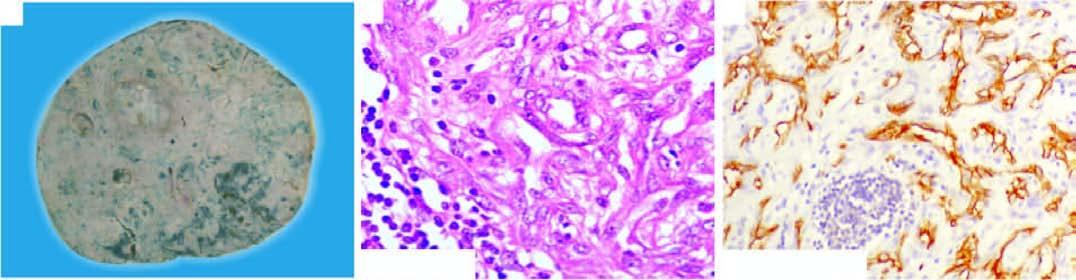what do the tumour cells show?
Answer the question using a single word or phrase. Proliferation of moderately pleomorphic anaplastic cells 